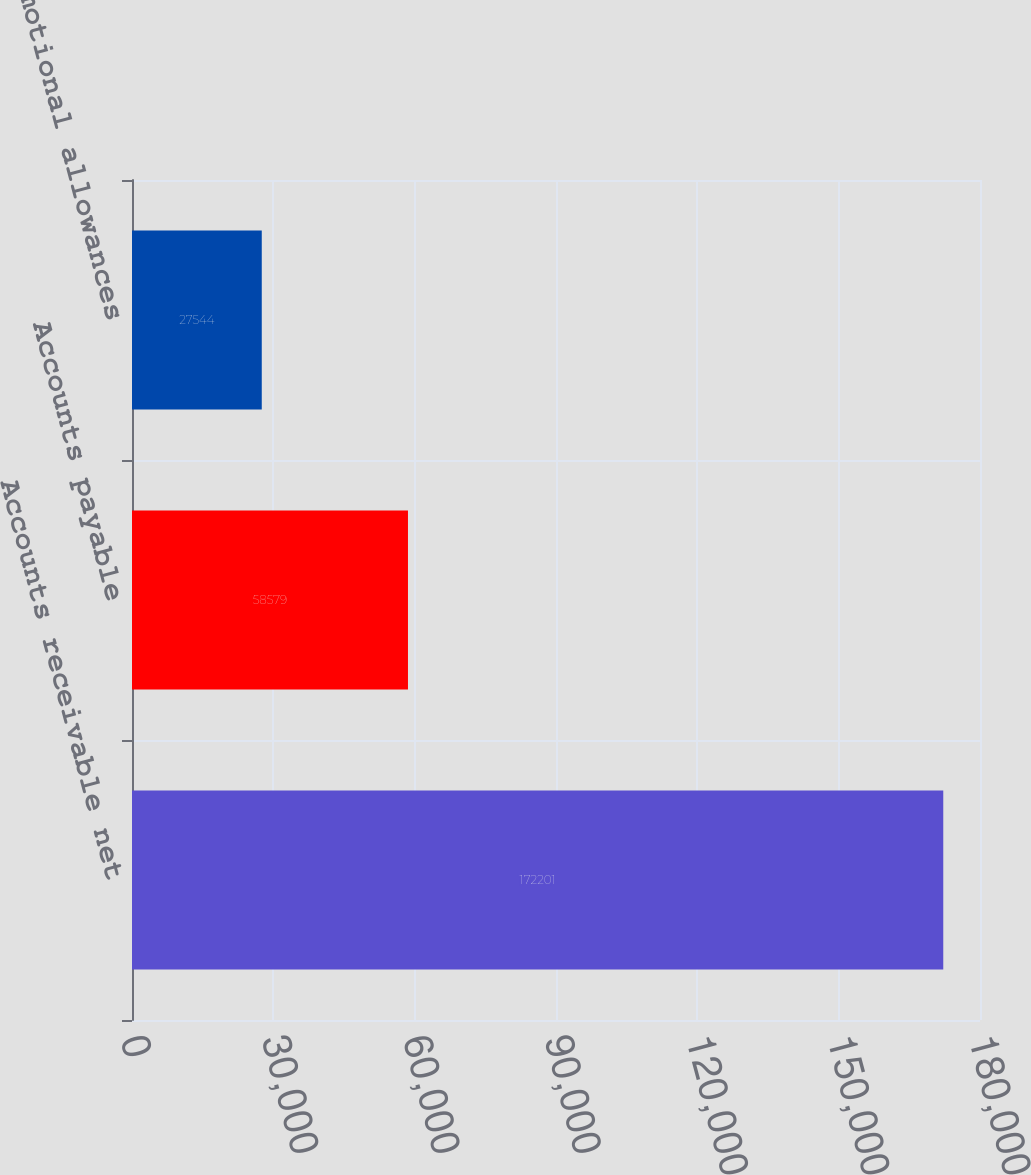Convert chart to OTSL. <chart><loc_0><loc_0><loc_500><loc_500><bar_chart><fcel>Accounts receivable net<fcel>Accounts payable<fcel>Accrued promotional allowances<nl><fcel>172201<fcel>58579<fcel>27544<nl></chart> 